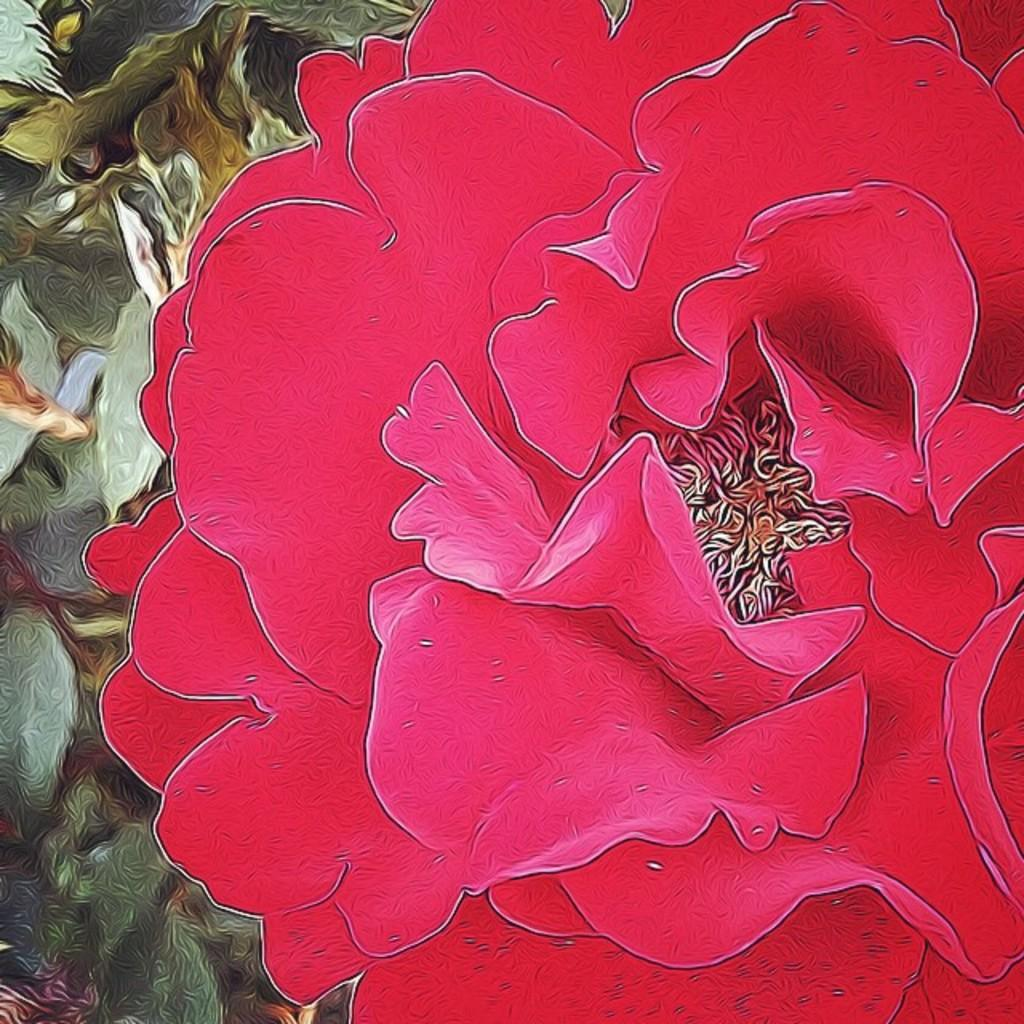What type of plant is present in the image? There is a red flower in the image. What type of curtain is used to cover the flower in the image? There is no curtain present in the image; it is a red flower without any covering. How does the flower maintain its balance in the image? The flower does not need to maintain its balance, as it is a static image and the flower is not moving or swaying. 